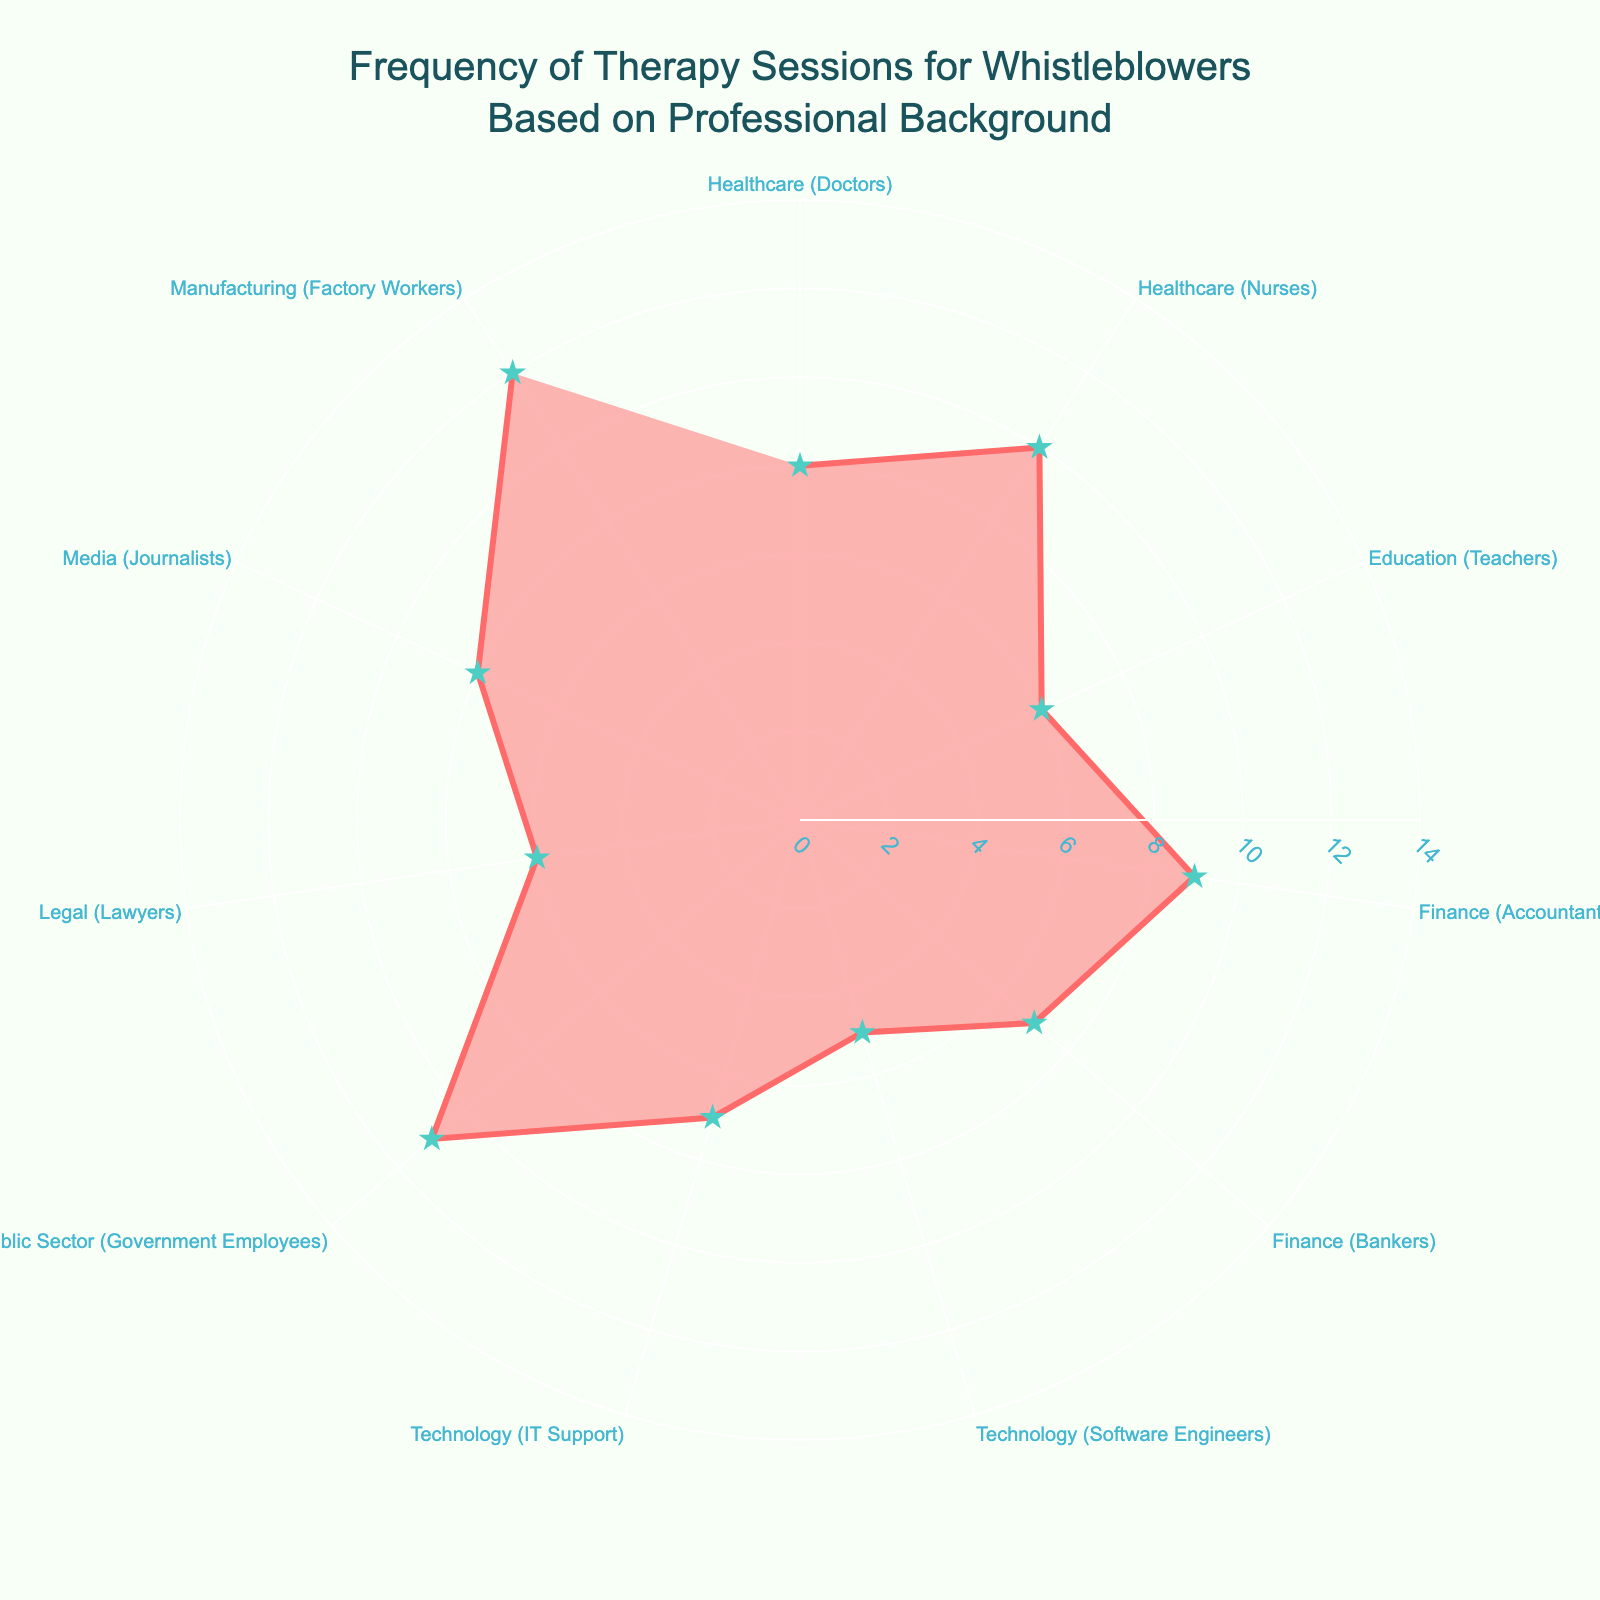what is the title of the figure? The title is located at the top of the figure and visualized clearly. It helps understand the context of the plot. The title states "Frequency of Therapy Sessions for Whistleblowers Based on Professional Background".
Answer: Frequency of Therapy Sessions for Whistleblowers Based on Professional Background How many professional backgrounds are represented in the figure? Each professional background is one of the categories distributed around the circular axis. By counting them, you can see there are eleven.
Answer: Eleven Which professional background requires the highest average number of sessions per month? By looking at the plot and checking the radial values for each category, the highest radial value corresponds to Manufacturing (Factory Workers), which is 12 sessions per month.
Answer: Manufacturing (Factory Workers) What is the range of average sessions per month shown in the figure? The minimum and maximum values of the radial axis indicate the range. In this plot, the range is from 0 to 14. The plotted data itself ranges from 5 to 12.
Answer: 5 to 12 Which professional backgrounds have an average of exactly 7 therapy sessions per month? By examining the plot, both Finance (Bankers) and Technology (IT Support) have points located exactly at the 7 session mark on the radial axis.
Answer: Finance (Bankers) and Technology (IT Support) What is the average number of therapy sessions per month for professionals in the Finance sector? Considering both professions in the Finance sector (Accountants and Bankers), their values are 9 and 7 sessions. The average of these values is (9 + 7)/2 = 8.
Answer: 8 How does the requirement for therapy sessions of teachers compare to that of journalists? Teachers have an average of 6 sessions per month, while Journalists have an average of 8 sessions. Subtracting these values, 8 - 6 results in Journalists requiring 2 more sessions per month compared to Teachers.
Answer: Journalists require 2 more sessions per month Which profession in the Healthcare sector has a higher average number of therapy sessions, Doctors or Nurses? By comparing the values on the plot, Healthcare (Nurses) requires 10 sessions per month, which is higher than Healthcare (Doctors) who require 8 sessions per month.
Answer: Healthcare (Nurses) What is the total number of therapy sessions required per month for all professional backgrounds combined? Summing the values of all the categories (8+10+6+9+7+5+7+11+6+8+12) results in 89 sessions per month in total.
Answer: 89 Among the listed professional backgrounds, which one has the least requirement of therapy sessions? By examining the radial scales, Technology (Software Engineers) has the lowest value of 5 sessions per month.
Answer: Technology (Software Engineers) 